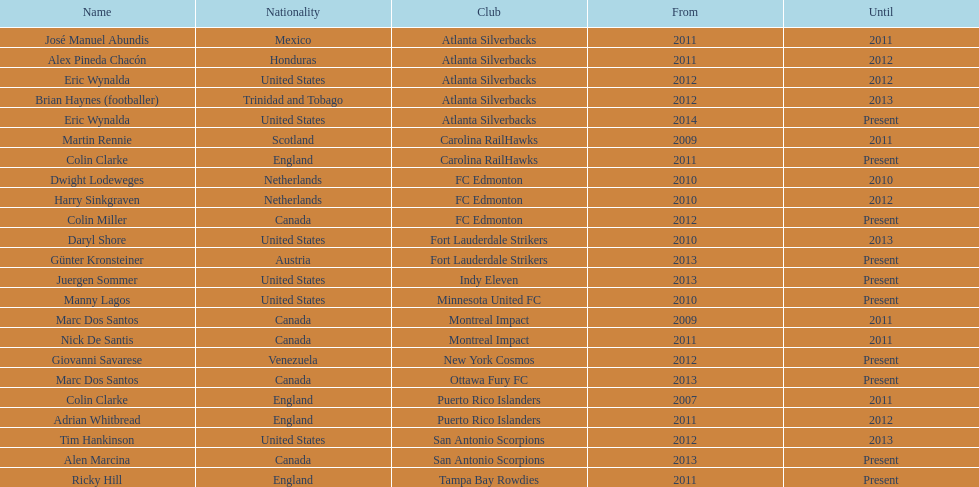What name is listed at the top? José Manuel Abundis. 